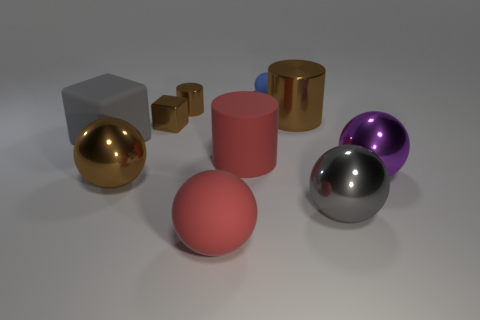Subtract all gray balls. How many balls are left? 4 Subtract all big purple spheres. How many spheres are left? 4 Subtract all cyan spheres. Subtract all red cubes. How many spheres are left? 5 Subtract all cylinders. How many objects are left? 7 Subtract 0 green blocks. How many objects are left? 10 Subtract all large purple objects. Subtract all cylinders. How many objects are left? 6 Add 9 brown metal cubes. How many brown metal cubes are left? 10 Add 4 small brown cylinders. How many small brown cylinders exist? 5 